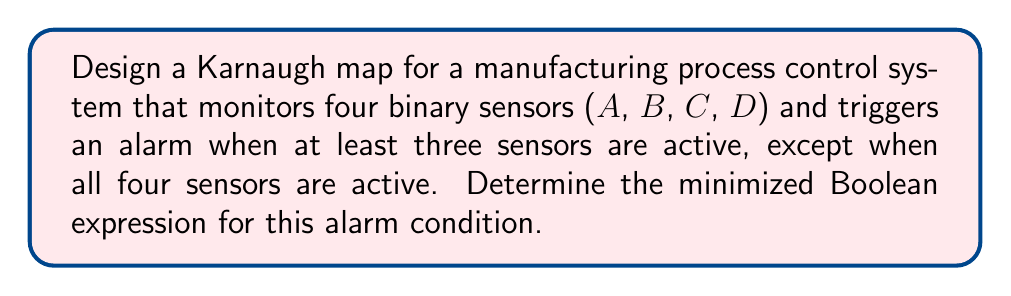Could you help me with this problem? 1. First, let's create a truth table for the given condition:

   A B C D | Alarm
   0 0 0 0 |   0
   0 0 0 1 |   0
   0 0 1 0 |   0
   0 0 1 1 |   0
   0 1 0 0 |   0
   0 1 0 1 |   0
   0 1 1 0 |   0
   0 1 1 1 |   1
   1 0 0 0 |   0
   1 0 0 1 |   0
   1 0 1 0 |   0
   1 0 1 1 |   1
   1 1 0 0 |   0
   1 1 0 1 |   1
   1 1 1 0 |   1
   1 1 1 1 |   0

2. Now, let's construct the Karnaugh map:

   [asy]
   unitsize(1cm);
   
   for(int i=0; i<4; ++i) {
     for(int j=0; j<4; ++j) {
       draw((i,j)--(i+1,j)--(i+1,j+1)--(i,j+1)--cycle);
     }
   }
   
   label("00", (0.5,4.5));
   label("01", (1.5,4.5));
   label("11", (2.5,4.5));
   label("10", (3.5,4.5));
   
   label("00", (-0.5,3.5));
   label("01", (-0.5,2.5));
   label("11", (-0.5,1.5));
   label("10", (-0.5,0.5));
   
   label("AB", (-0.5,4.5));
   label("CD", (4.5,3.5));
   
   label("0", (0.5,3.5));
   label("0", (1.5,3.5));
   label("0", (2.5,3.5));
   label("0", (3.5,3.5));
   
   label("0", (0.5,2.5));
   label("0", (1.5,2.5));
   label("1", (2.5,2.5));
   label("0", (3.5,2.5));
   
   label("0", (0.5,1.5));
   label("1", (1.5,1.5));
   label("0", (2.5,1.5));
   label("1", (3.5,1.5));
   
   label("0", (0.5,0.5));
   label("0", (1.5,0.5));
   label("1", (2.5,0.5));
   label("0", (3.5,0.5));
   [/asy]

3. Identify the groups of 1's in the Karnaugh map. We can see three groups of 2 cells:
   - Group 1: $\overline{A}BCD$ and $\overline{A}BC\overline{D}$
   - Group 2: $AB\overline{C}D$ and $A\overline{B}CD$
   - Group 3: $ABC\overline{D}$ and $AB\overline{C}D$

4. Write the minimized Boolean expression for each group:
   - Group 1: $\overline{A}BC$
   - Group 2: $ABD$
   - Group 3: $AB\overline{D}$

5. Combine the expressions using OR operations:

   Alarm = $\overline{A}BC + ABD + AB\overline{D}$

This minimized Boolean expression represents the alarm condition for the manufacturing process control system.
Answer: $\overline{A}BC + ABD + AB\overline{D}$ 